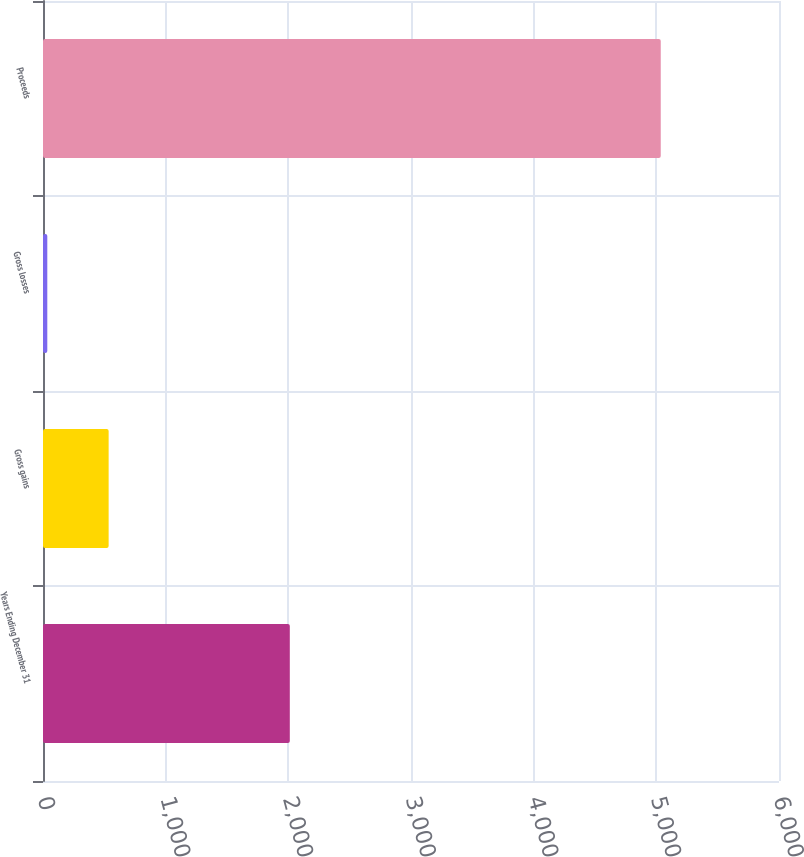Convert chart. <chart><loc_0><loc_0><loc_500><loc_500><bar_chart><fcel>Years Ending December 31<fcel>Gross gains<fcel>Gross losses<fcel>Proceeds<nl><fcel>2012<fcel>535.1<fcel>35<fcel>5036<nl></chart> 